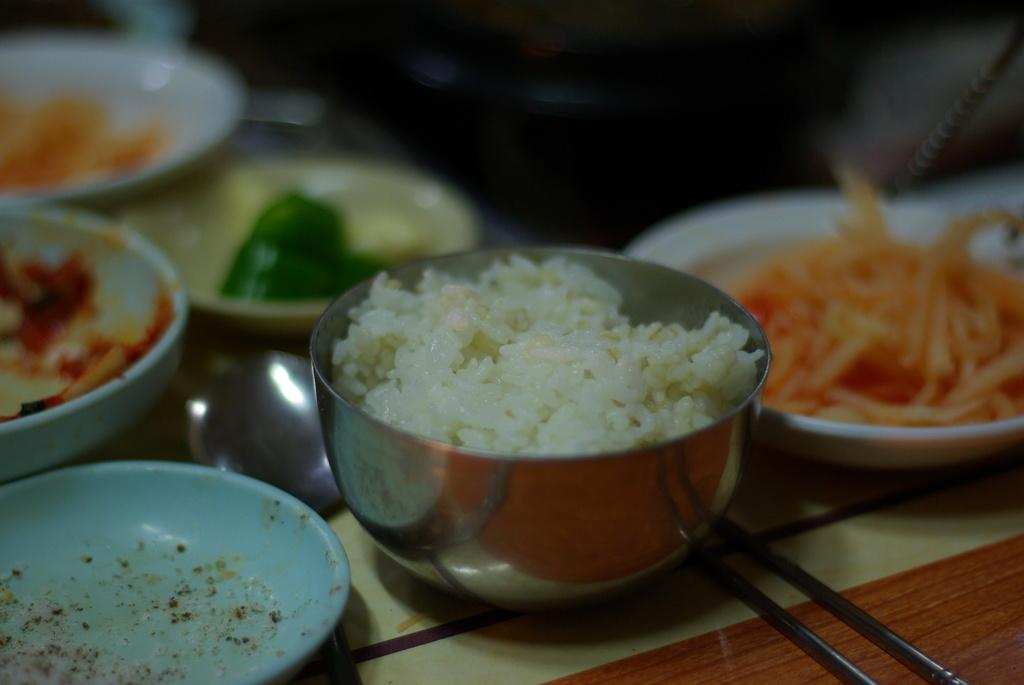What is in the bowl that is visible in the image? There is a bowl of rice in the image. Besides the bowl of rice, what other food items can be seen in the image? There are plates with food items in the image. What utensil is present in the image? There is a spoon-like object in the image. What type of utensil is also present in the image? There are chopsticks in the image. What type of bird is in the jail in the image? There is no bird or jail present in the image. What is the cause of death in the image? There is no death or any indication of a cause of death in the image. 